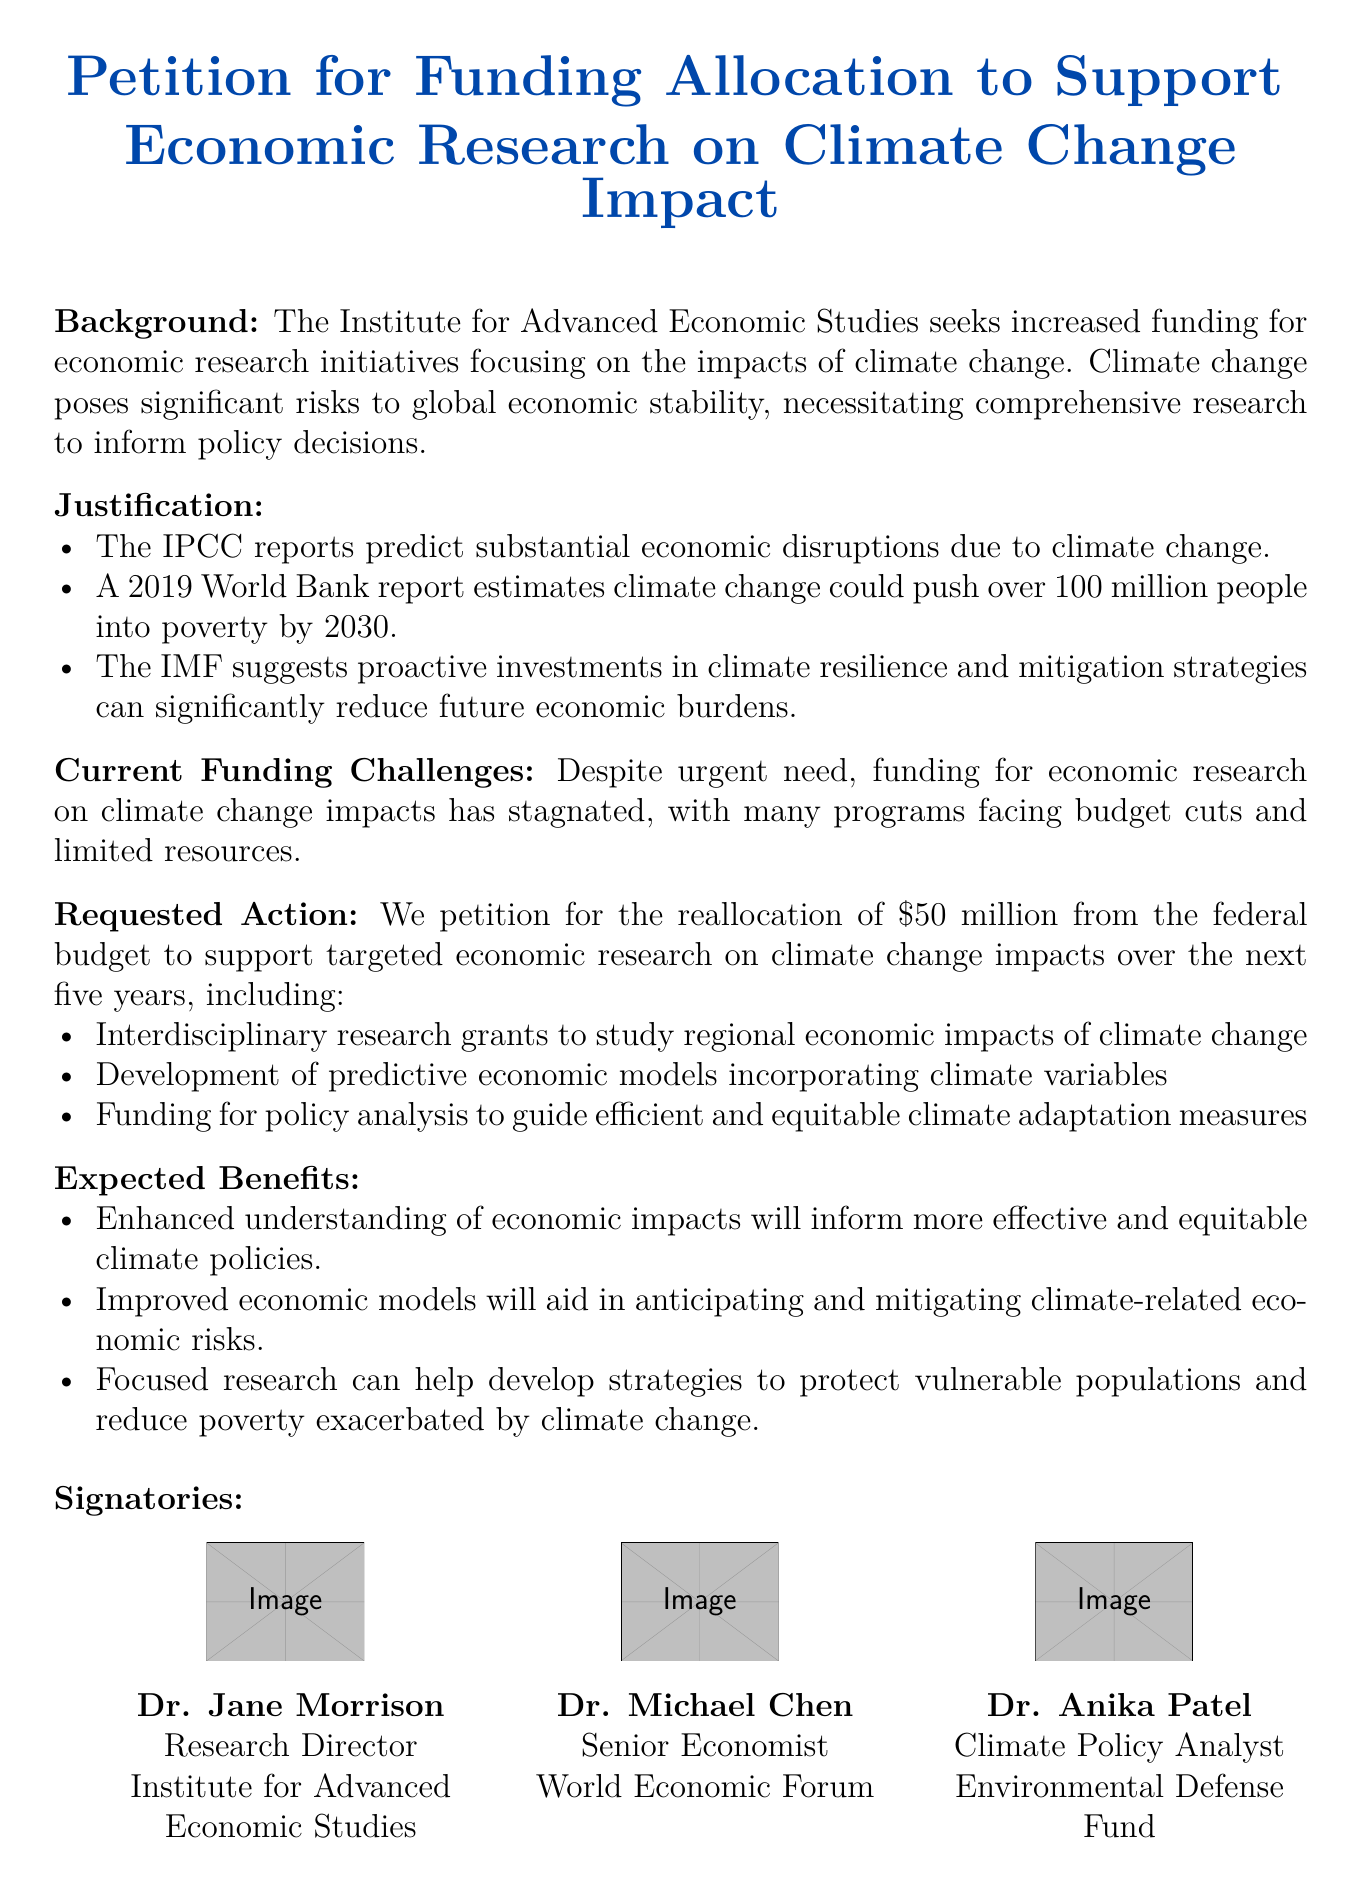What is the total funding requested? The total funding requested is explicitly stated in the document as \$50 million.
Answer: \$50 million Who is the Research Director mentioned in the document? The document lists Dr. Jane Morrison as the Research Director of the Institute for Advanced Economic Studies.
Answer: Dr. Jane Morrison What are the two types of research grants requested? The document mentions "interdisciplinary research grants" and "development of predictive economic models" as the types of research grants requested.
Answer: interdisciplinary research grants, development of predictive economic models What is one expected benefit from the proposed research? The document states that "Enhanced understanding of economic impacts will inform more effective and equitable climate policies" as one of the expected benefits.
Answer: Enhanced understanding of economic impacts Which organization is Dr. Michael Chen associated with? The document indicates that Dr. Michael Chen is a Senior Economist at the World Economic Forum.
Answer: World Economic Forum What significant report does the document reference that estimates poverty escalation? The document refers to a "2019 World Bank report" estimating that climate change could push over 100 million people into poverty.
Answer: 2019 World Bank report 